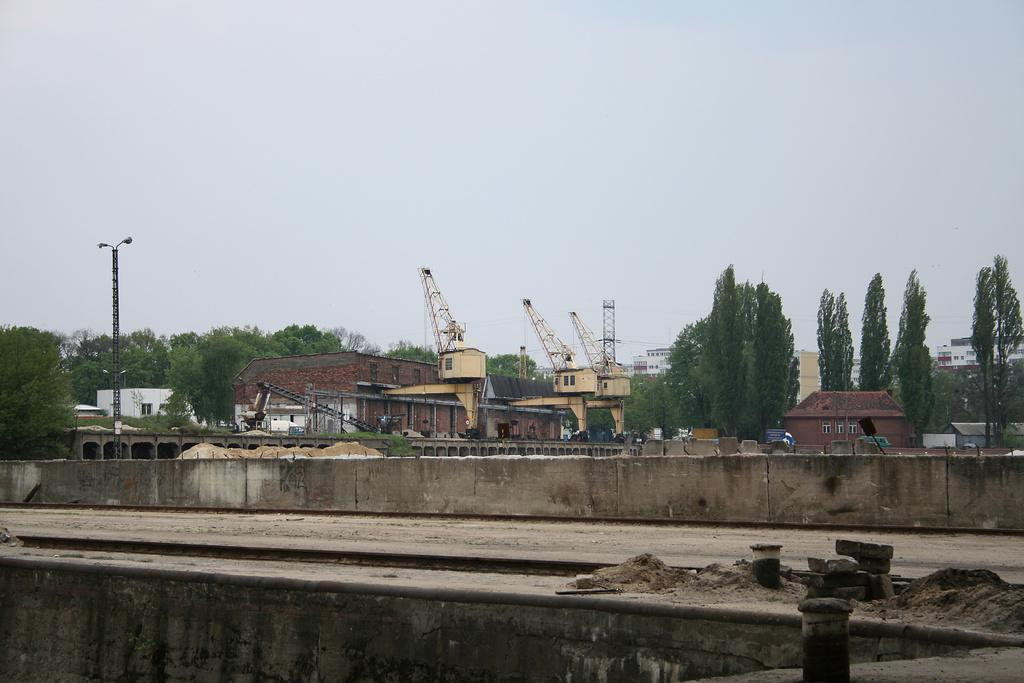What type of structures are located in the middle of the image? There are houses in the middle of the image. What other objects can be seen in the middle of the image? There are trees, streetlights, stones, a wall, and machines in the middle of the image. What is visible in the background of the image? The sky is visible in the image. What type of agreement can be seen in the image? There is no agreement present in the image; it features houses, trees, streetlights, stones, a wall, machines, and the sky. 